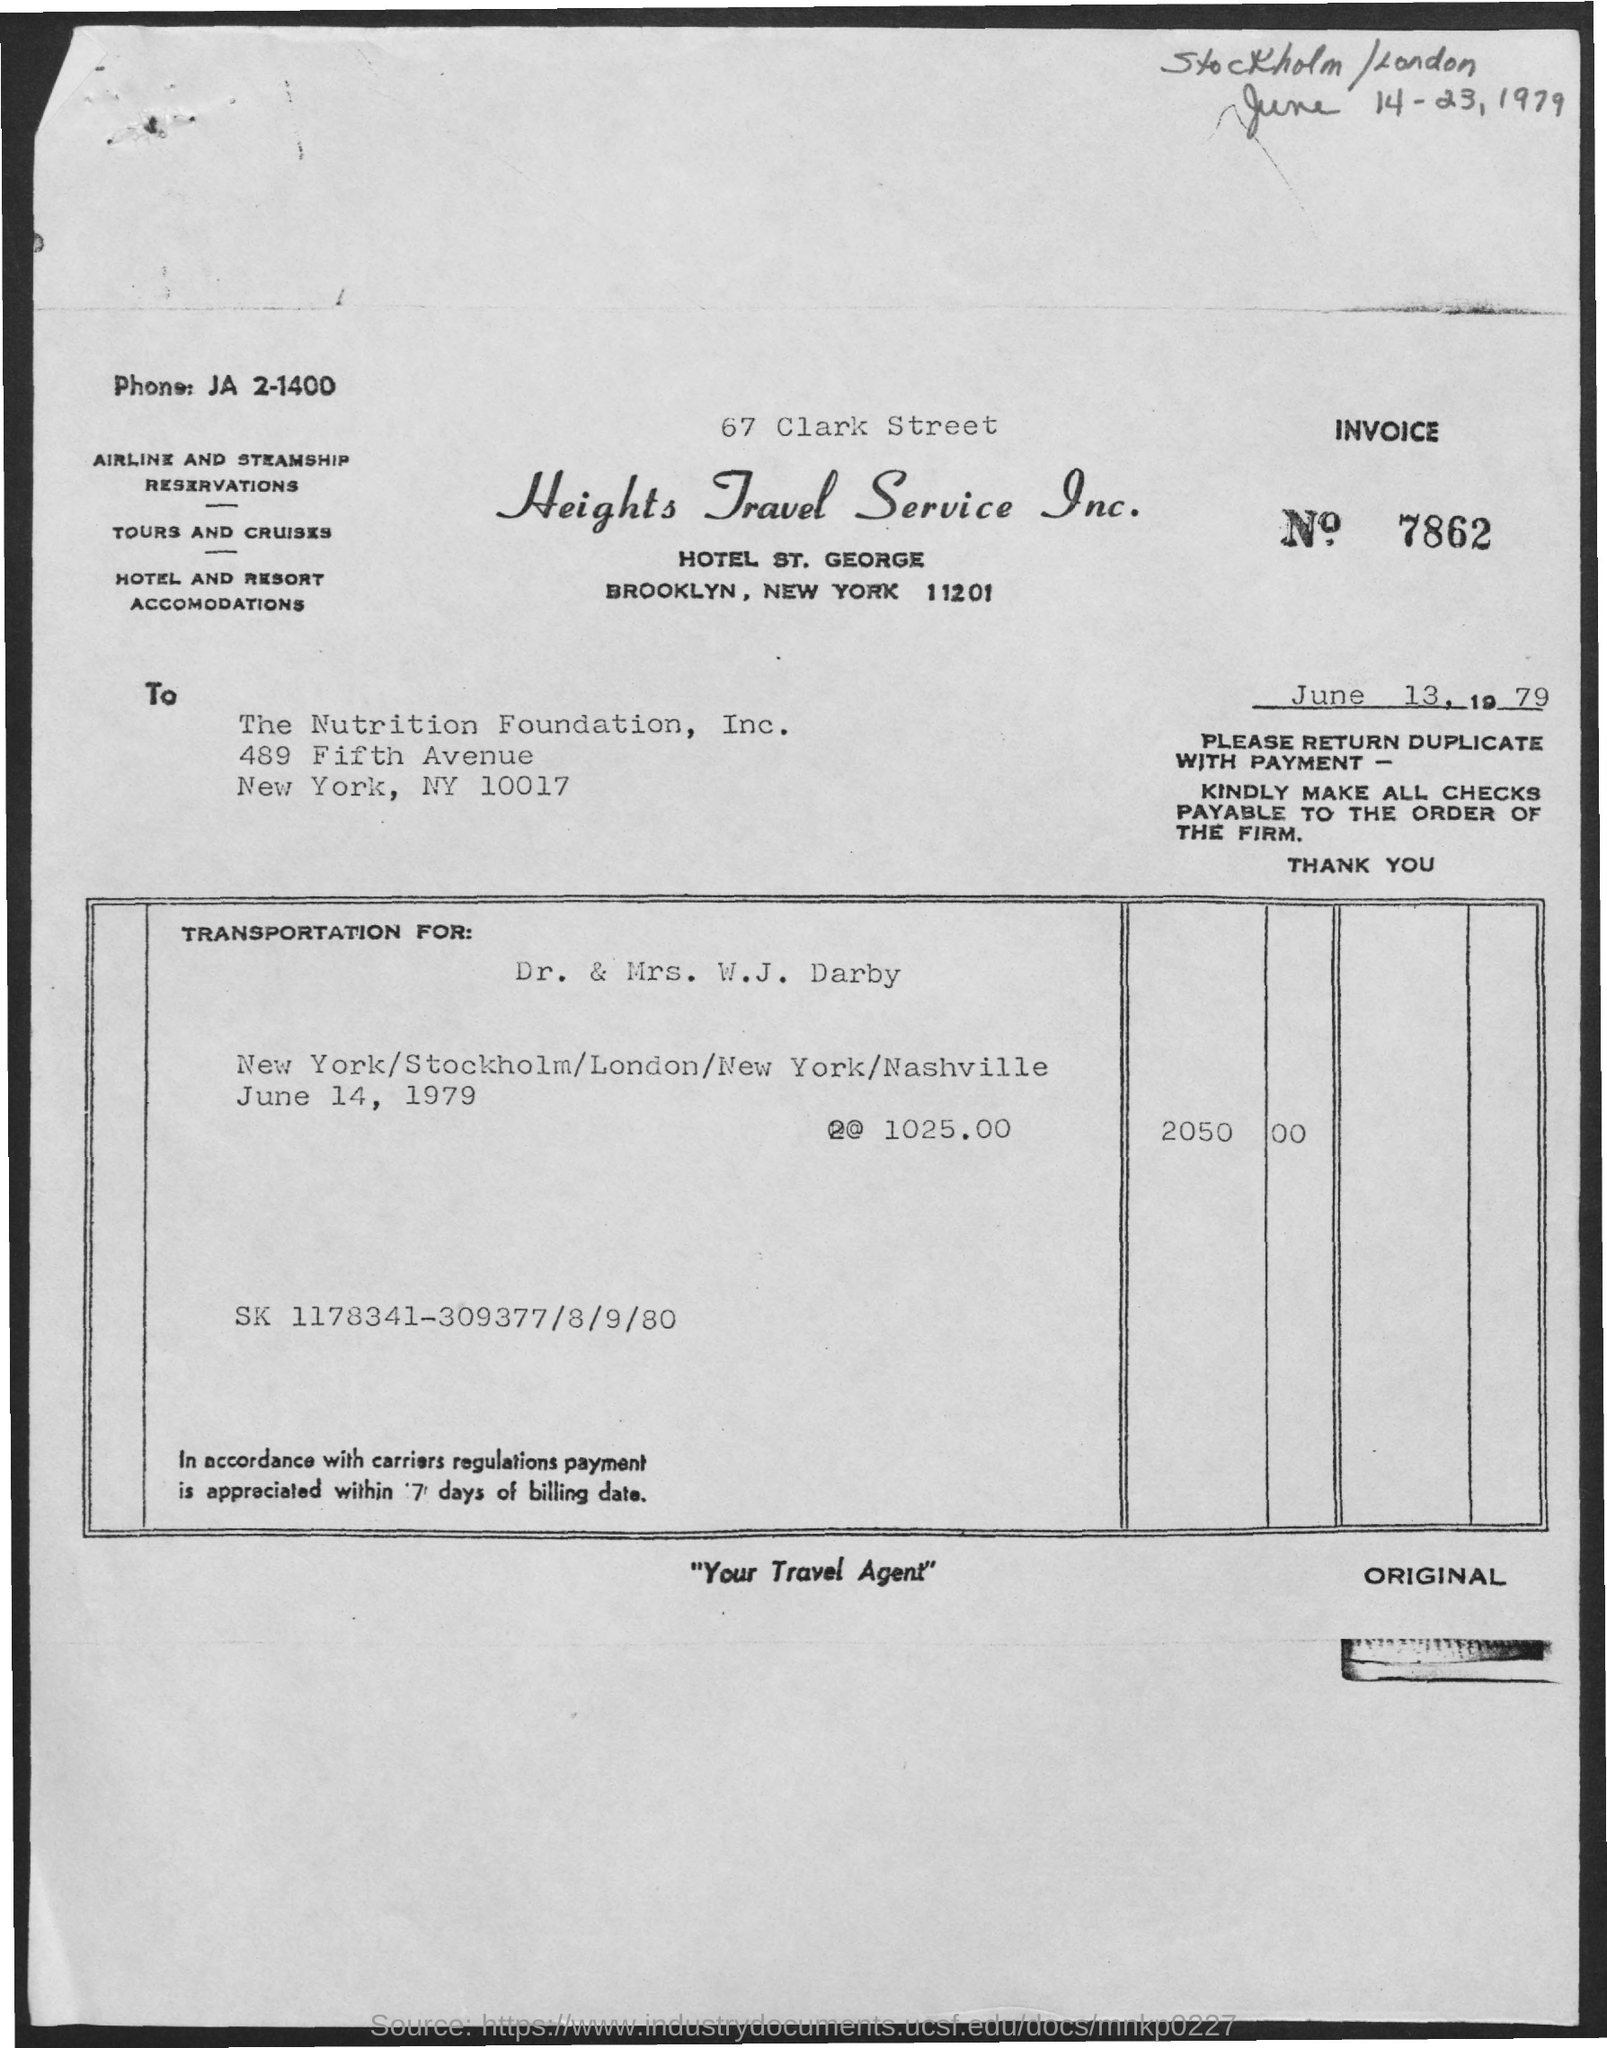Mention a couple of crucial points in this snapshot. The Invoice No. is 7862... The total amount is 2050.00. The transportation is intended for Dr. and Mrs. W.J. Darby. 